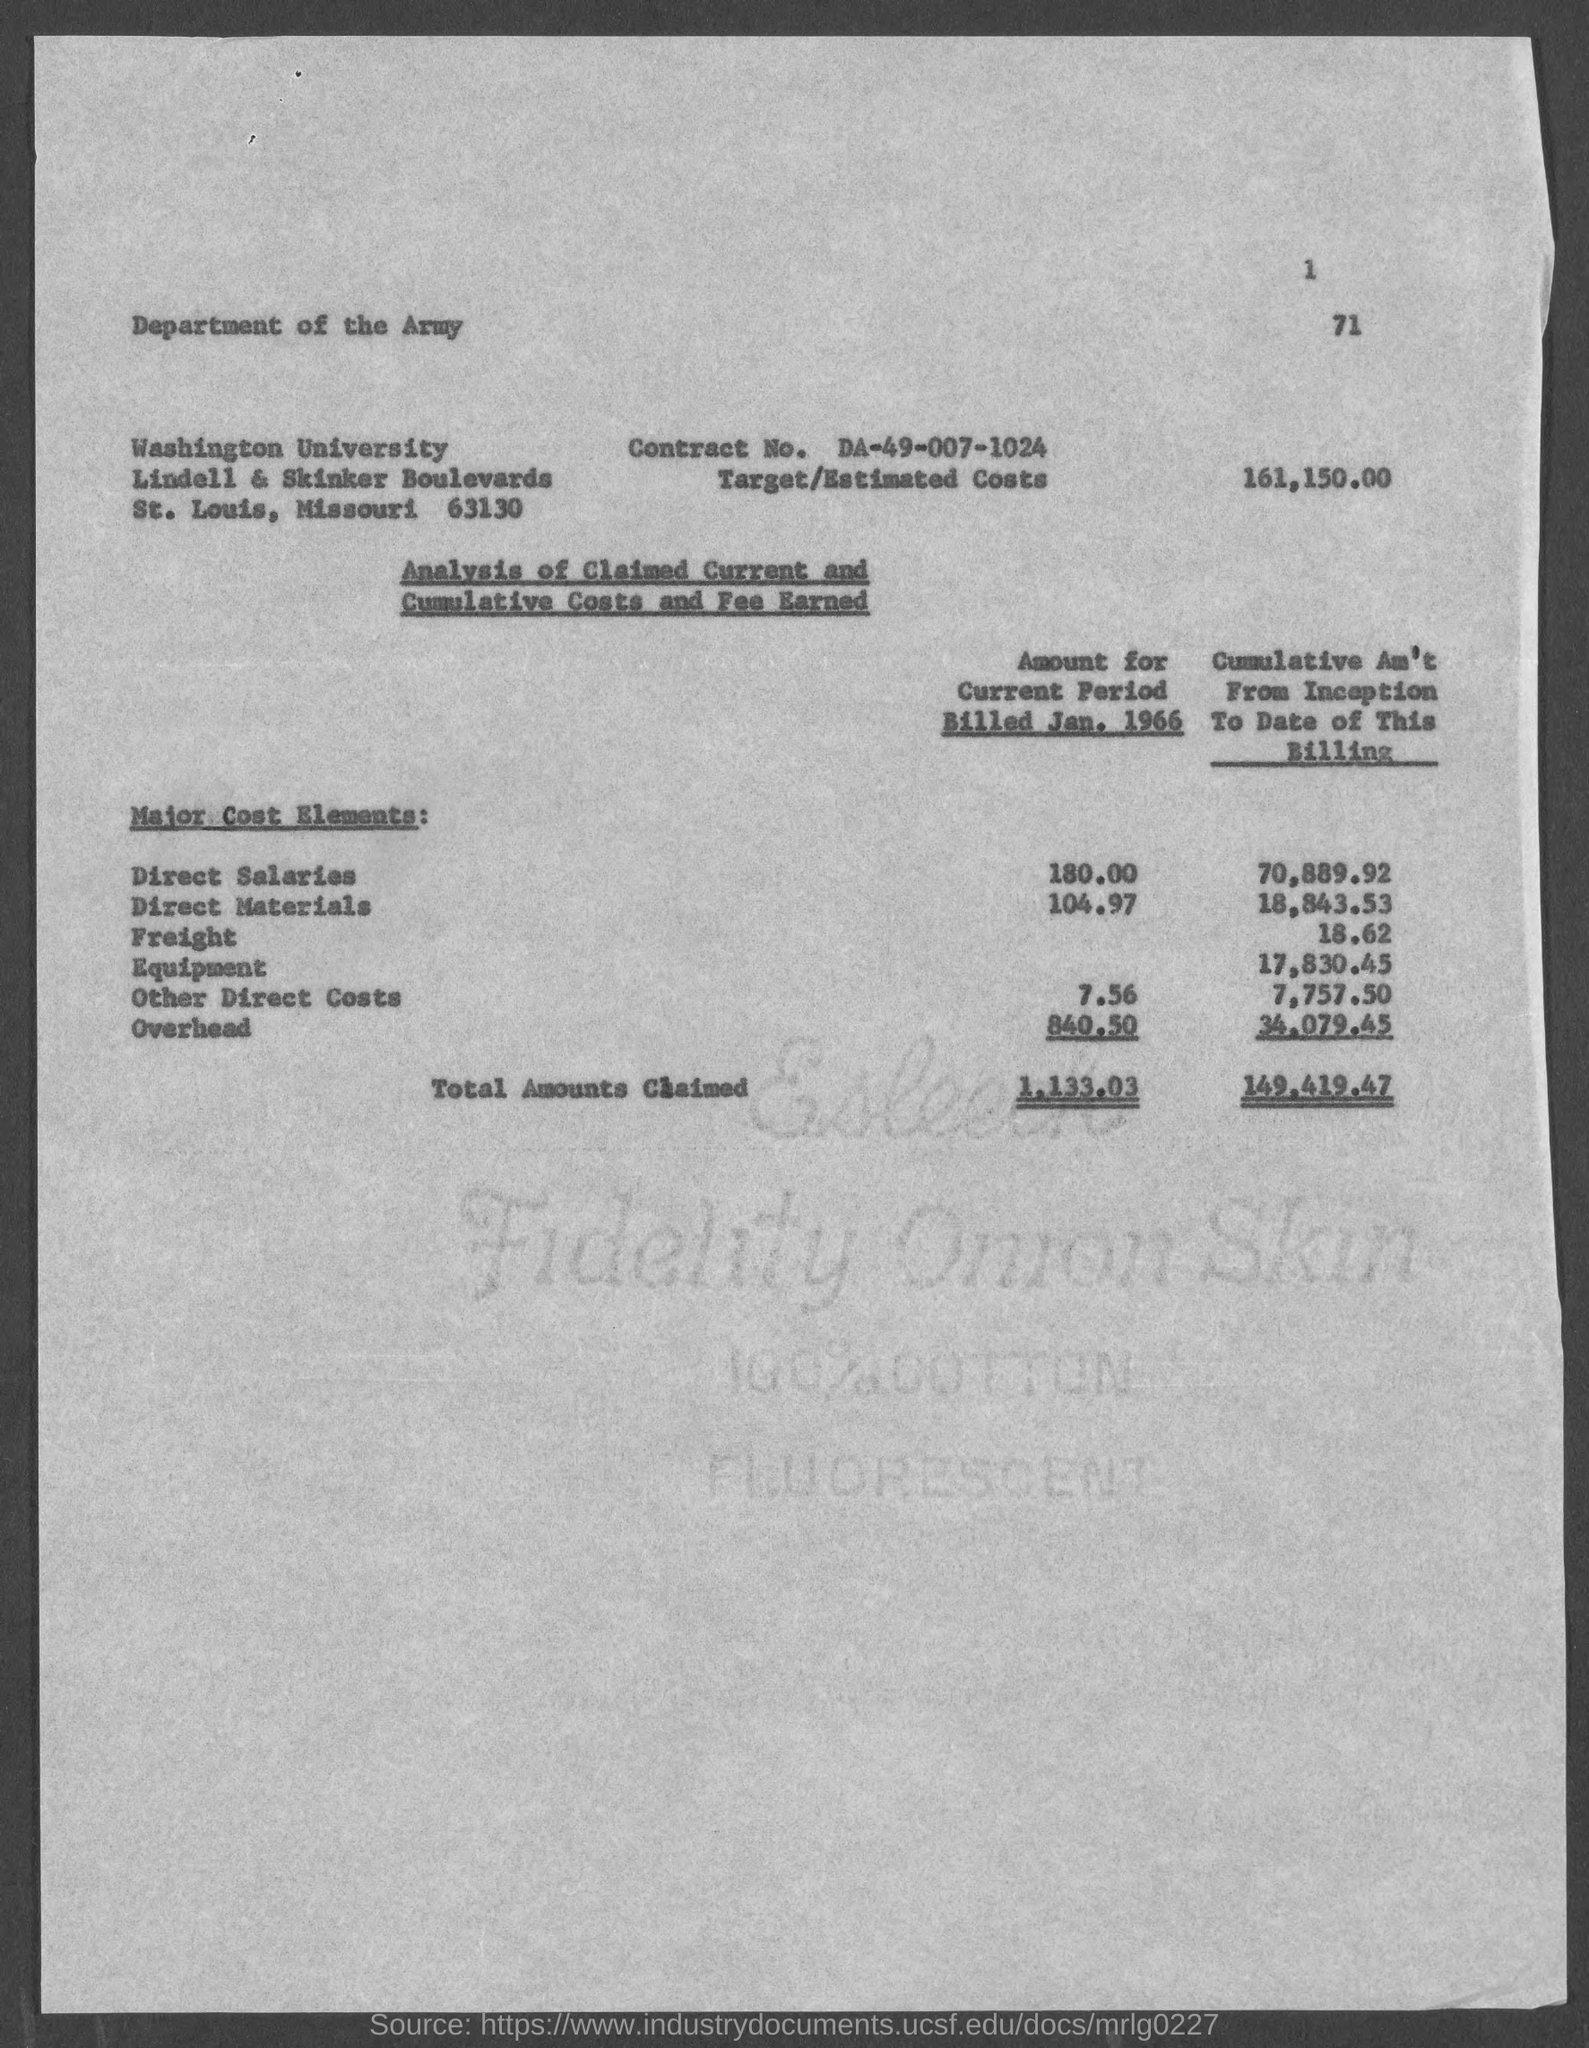List a handful of essential elements in this visual. The direct salary amount for the current period billed in January 1966 was $180.00. The Direct Materials amount for the current period billed in January 1966 was $104.97. The other direct costs amount for the current period billed in January 1966 is $7.56. The estimated cost for the project is 161,150.00. The total amount claimed for the cumulative amount from the inception to the current date of this billing is 149,419.47. 